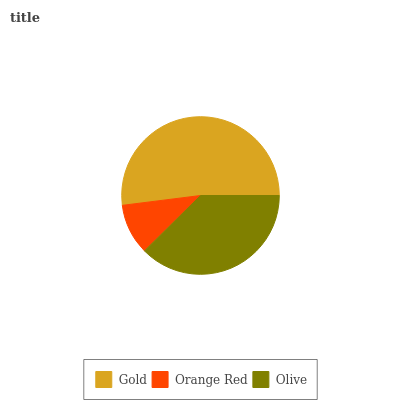Is Orange Red the minimum?
Answer yes or no. Yes. Is Gold the maximum?
Answer yes or no. Yes. Is Olive the minimum?
Answer yes or no. No. Is Olive the maximum?
Answer yes or no. No. Is Olive greater than Orange Red?
Answer yes or no. Yes. Is Orange Red less than Olive?
Answer yes or no. Yes. Is Orange Red greater than Olive?
Answer yes or no. No. Is Olive less than Orange Red?
Answer yes or no. No. Is Olive the high median?
Answer yes or no. Yes. Is Olive the low median?
Answer yes or no. Yes. Is Orange Red the high median?
Answer yes or no. No. Is Gold the low median?
Answer yes or no. No. 